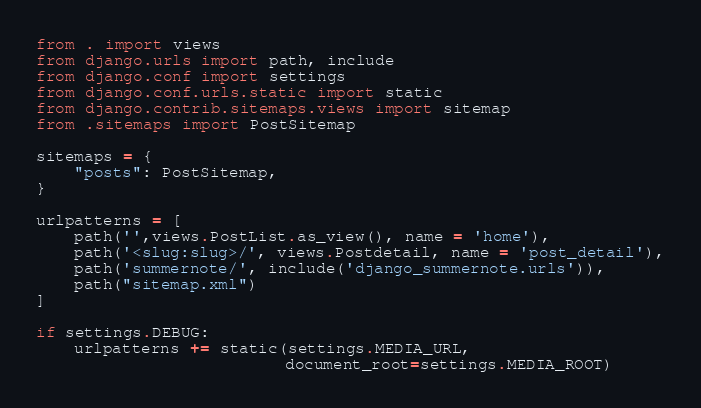Convert code to text. <code><loc_0><loc_0><loc_500><loc_500><_Python_>from . import views
from django.urls import path, include
from django.conf import settings
from django.conf.urls.static import static
from django.contrib.sitemaps.views import sitemap
from .sitemaps import PostSitemap

sitemaps = {
    "posts": PostSitemap,
}

urlpatterns = [
    path('',views.PostList.as_view(), name = 'home'),
    path('<slug:slug>/', views.Postdetail, name = 'post_detail'),
    path('summernote/', include('django_summernote.urls')),
    path("sitemap.xml")
]

if settings.DEBUG:
    urlpatterns += static(settings.MEDIA_URL,
                          document_root=settings.MEDIA_ROOT)</code> 